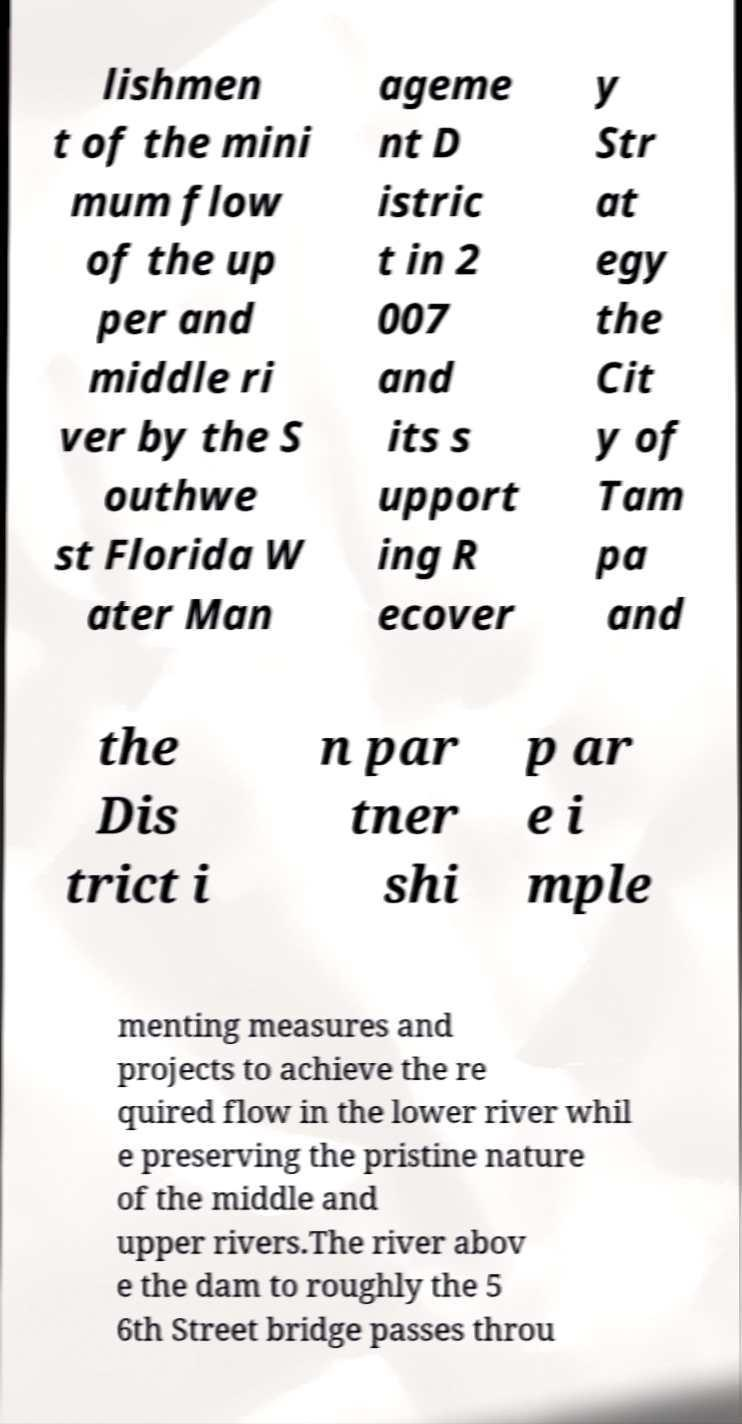Can you read and provide the text displayed in the image?This photo seems to have some interesting text. Can you extract and type it out for me? lishmen t of the mini mum flow of the up per and middle ri ver by the S outhwe st Florida W ater Man ageme nt D istric t in 2 007 and its s upport ing R ecover y Str at egy the Cit y of Tam pa and the Dis trict i n par tner shi p ar e i mple menting measures and projects to achieve the re quired flow in the lower river whil e preserving the pristine nature of the middle and upper rivers.The river abov e the dam to roughly the 5 6th Street bridge passes throu 